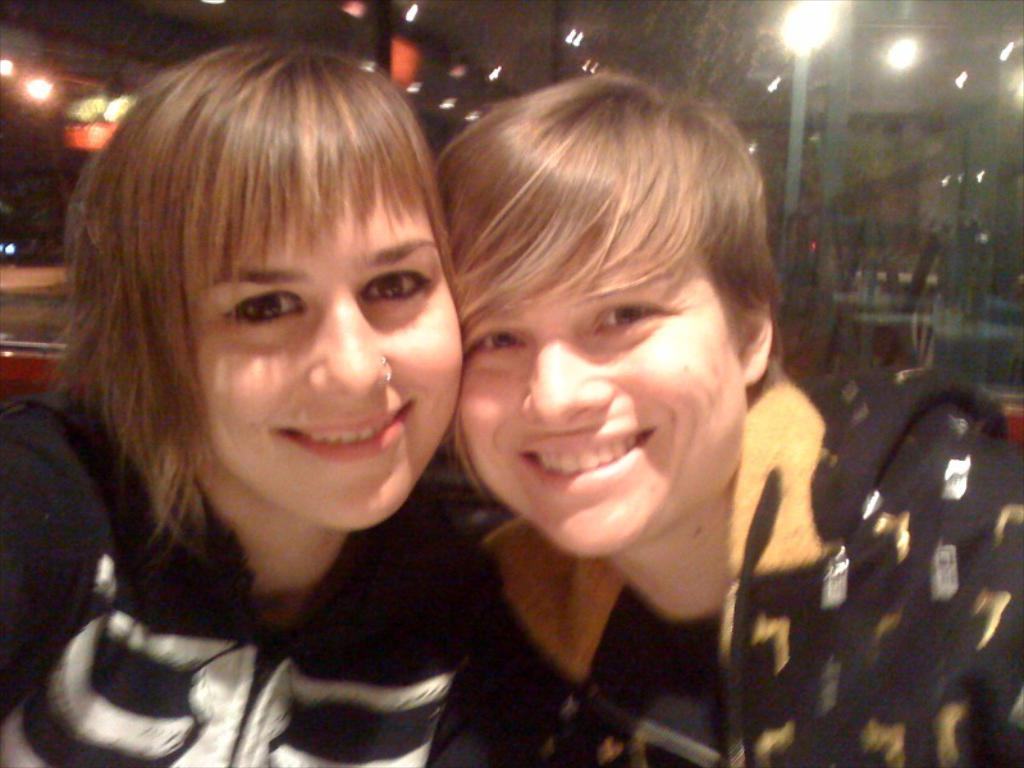What are the people in the image doing? There are humans sitting in the image. What can be seen illuminating the scene in the image? There are lights visible in the image. What are the people sitting on in the image? There are chairs in the image. What can be seen in the distance in the image? There are buildings in the background of the image. Where is the nest located in the image? There is no nest present in the image. What type of coal is being used to fuel the lights in the image? The image does not show any coal being used to fuel the lights; the lights are likely powered by electricity. 